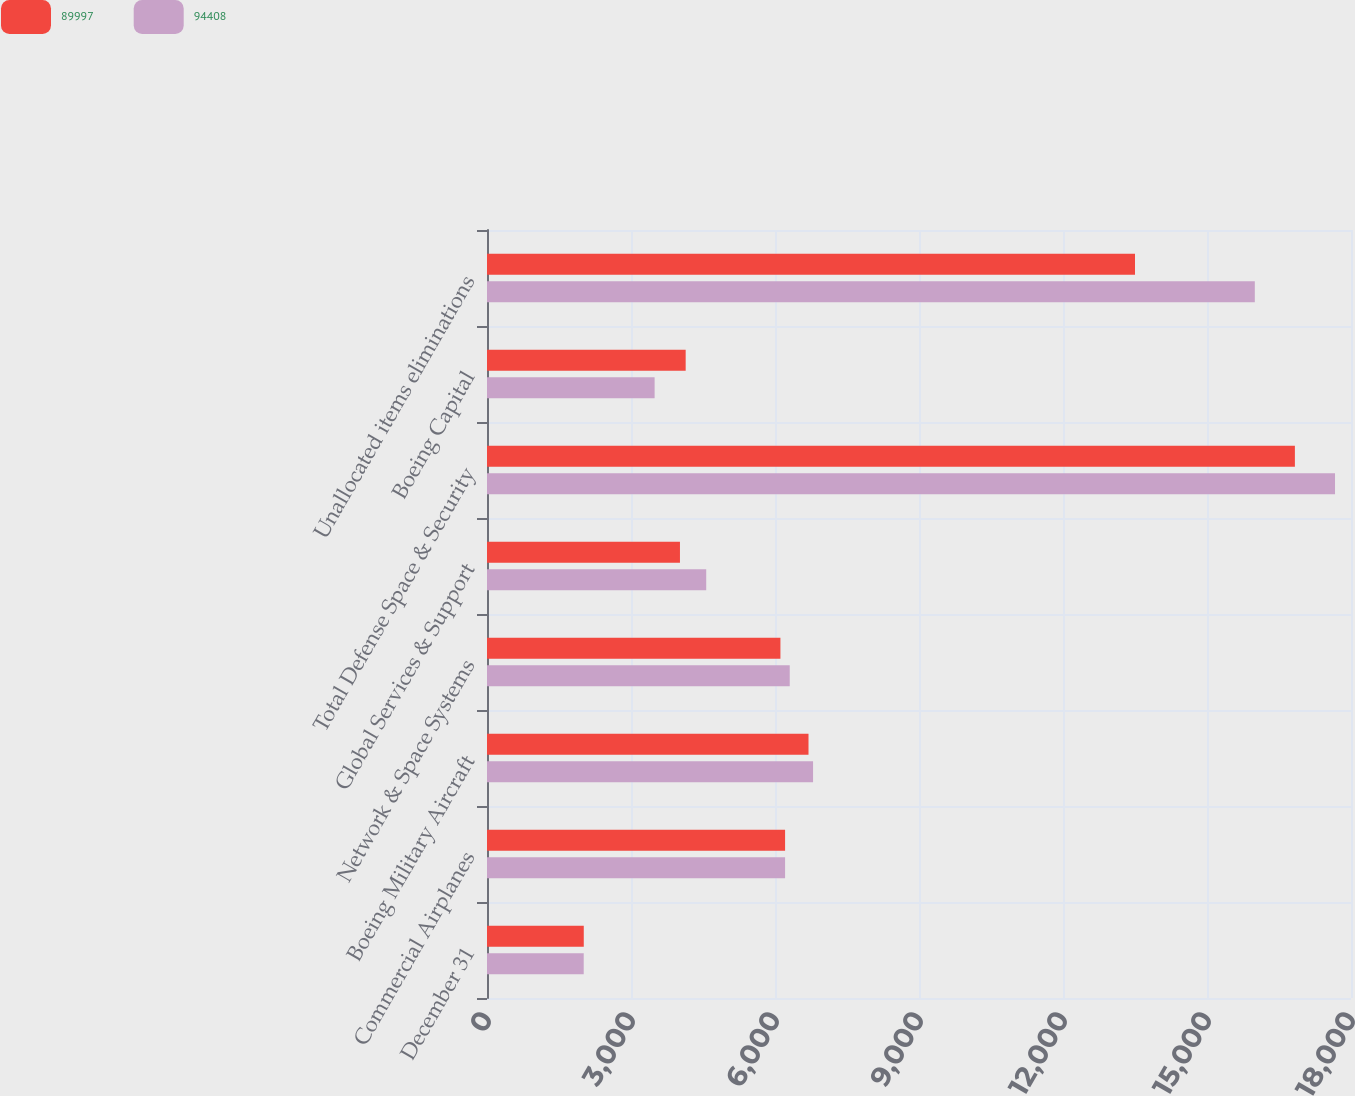Convert chart to OTSL. <chart><loc_0><loc_0><loc_500><loc_500><stacked_bar_chart><ecel><fcel>December 31<fcel>Commercial Airplanes<fcel>Boeing Military Aircraft<fcel>Network & Space Systems<fcel>Global Services & Support<fcel>Total Defense Space & Security<fcel>Boeing Capital<fcel>Unallocated items eliminations<nl><fcel>89997<fcel>2016<fcel>6210<fcel>6698<fcel>6113<fcel>4020<fcel>16831<fcel>4139<fcel>13500<nl><fcel>94408<fcel>2015<fcel>6210<fcel>6793<fcel>6307<fcel>4567<fcel>17667<fcel>3492<fcel>15996<nl></chart> 